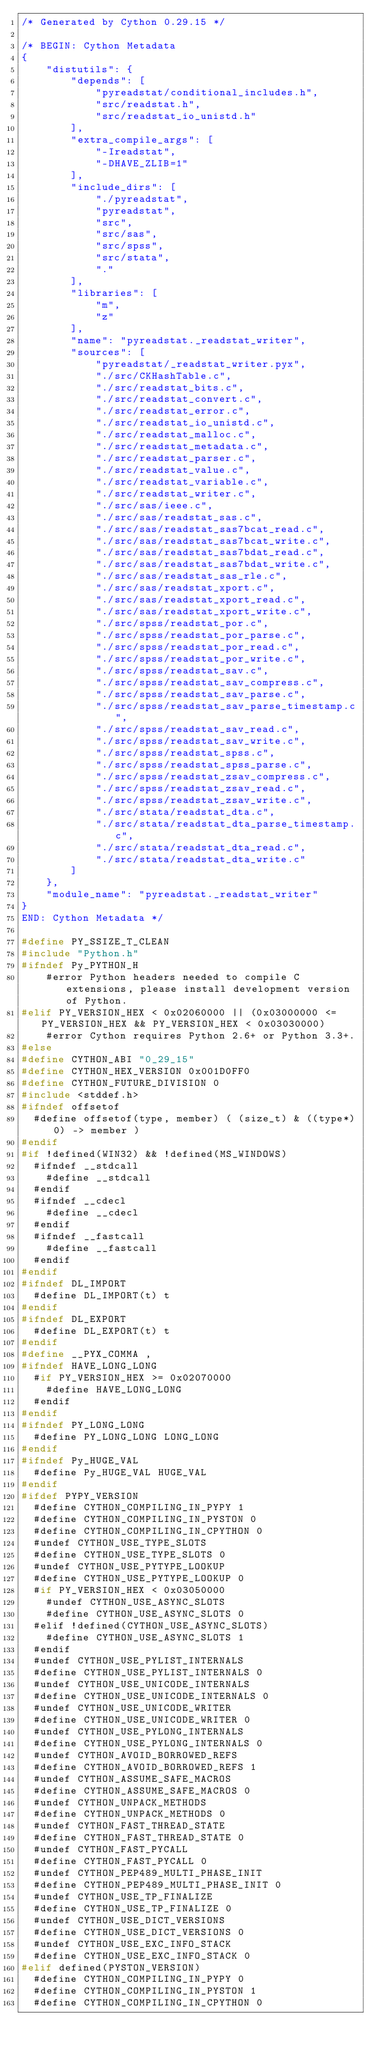Convert code to text. <code><loc_0><loc_0><loc_500><loc_500><_C_>/* Generated by Cython 0.29.15 */

/* BEGIN: Cython Metadata
{
    "distutils": {
        "depends": [
            "pyreadstat/conditional_includes.h",
            "src/readstat.h",
            "src/readstat_io_unistd.h"
        ],
        "extra_compile_args": [
            "-Ireadstat",
            "-DHAVE_ZLIB=1"
        ],
        "include_dirs": [
            "./pyreadstat",
            "pyreadstat",
            "src",
            "src/sas",
            "src/spss",
            "src/stata",
            "."
        ],
        "libraries": [
            "m",
            "z"
        ],
        "name": "pyreadstat._readstat_writer",
        "sources": [
            "pyreadstat/_readstat_writer.pyx",
            "./src/CKHashTable.c",
            "./src/readstat_bits.c",
            "./src/readstat_convert.c",
            "./src/readstat_error.c",
            "./src/readstat_io_unistd.c",
            "./src/readstat_malloc.c",
            "./src/readstat_metadata.c",
            "./src/readstat_parser.c",
            "./src/readstat_value.c",
            "./src/readstat_variable.c",
            "./src/readstat_writer.c",
            "./src/sas/ieee.c",
            "./src/sas/readstat_sas.c",
            "./src/sas/readstat_sas7bcat_read.c",
            "./src/sas/readstat_sas7bcat_write.c",
            "./src/sas/readstat_sas7bdat_read.c",
            "./src/sas/readstat_sas7bdat_write.c",
            "./src/sas/readstat_sas_rle.c",
            "./src/sas/readstat_xport.c",
            "./src/sas/readstat_xport_read.c",
            "./src/sas/readstat_xport_write.c",
            "./src/spss/readstat_por.c",
            "./src/spss/readstat_por_parse.c",
            "./src/spss/readstat_por_read.c",
            "./src/spss/readstat_por_write.c",
            "./src/spss/readstat_sav.c",
            "./src/spss/readstat_sav_compress.c",
            "./src/spss/readstat_sav_parse.c",
            "./src/spss/readstat_sav_parse_timestamp.c",
            "./src/spss/readstat_sav_read.c",
            "./src/spss/readstat_sav_write.c",
            "./src/spss/readstat_spss.c",
            "./src/spss/readstat_spss_parse.c",
            "./src/spss/readstat_zsav_compress.c",
            "./src/spss/readstat_zsav_read.c",
            "./src/spss/readstat_zsav_write.c",
            "./src/stata/readstat_dta.c",
            "./src/stata/readstat_dta_parse_timestamp.c",
            "./src/stata/readstat_dta_read.c",
            "./src/stata/readstat_dta_write.c"
        ]
    },
    "module_name": "pyreadstat._readstat_writer"
}
END: Cython Metadata */

#define PY_SSIZE_T_CLEAN
#include "Python.h"
#ifndef Py_PYTHON_H
    #error Python headers needed to compile C extensions, please install development version of Python.
#elif PY_VERSION_HEX < 0x02060000 || (0x03000000 <= PY_VERSION_HEX && PY_VERSION_HEX < 0x03030000)
    #error Cython requires Python 2.6+ or Python 3.3+.
#else
#define CYTHON_ABI "0_29_15"
#define CYTHON_HEX_VERSION 0x001D0FF0
#define CYTHON_FUTURE_DIVISION 0
#include <stddef.h>
#ifndef offsetof
  #define offsetof(type, member) ( (size_t) & ((type*)0) -> member )
#endif
#if !defined(WIN32) && !defined(MS_WINDOWS)
  #ifndef __stdcall
    #define __stdcall
  #endif
  #ifndef __cdecl
    #define __cdecl
  #endif
  #ifndef __fastcall
    #define __fastcall
  #endif
#endif
#ifndef DL_IMPORT
  #define DL_IMPORT(t) t
#endif
#ifndef DL_EXPORT
  #define DL_EXPORT(t) t
#endif
#define __PYX_COMMA ,
#ifndef HAVE_LONG_LONG
  #if PY_VERSION_HEX >= 0x02070000
    #define HAVE_LONG_LONG
  #endif
#endif
#ifndef PY_LONG_LONG
  #define PY_LONG_LONG LONG_LONG
#endif
#ifndef Py_HUGE_VAL
  #define Py_HUGE_VAL HUGE_VAL
#endif
#ifdef PYPY_VERSION
  #define CYTHON_COMPILING_IN_PYPY 1
  #define CYTHON_COMPILING_IN_PYSTON 0
  #define CYTHON_COMPILING_IN_CPYTHON 0
  #undef CYTHON_USE_TYPE_SLOTS
  #define CYTHON_USE_TYPE_SLOTS 0
  #undef CYTHON_USE_PYTYPE_LOOKUP
  #define CYTHON_USE_PYTYPE_LOOKUP 0
  #if PY_VERSION_HEX < 0x03050000
    #undef CYTHON_USE_ASYNC_SLOTS
    #define CYTHON_USE_ASYNC_SLOTS 0
  #elif !defined(CYTHON_USE_ASYNC_SLOTS)
    #define CYTHON_USE_ASYNC_SLOTS 1
  #endif
  #undef CYTHON_USE_PYLIST_INTERNALS
  #define CYTHON_USE_PYLIST_INTERNALS 0
  #undef CYTHON_USE_UNICODE_INTERNALS
  #define CYTHON_USE_UNICODE_INTERNALS 0
  #undef CYTHON_USE_UNICODE_WRITER
  #define CYTHON_USE_UNICODE_WRITER 0
  #undef CYTHON_USE_PYLONG_INTERNALS
  #define CYTHON_USE_PYLONG_INTERNALS 0
  #undef CYTHON_AVOID_BORROWED_REFS
  #define CYTHON_AVOID_BORROWED_REFS 1
  #undef CYTHON_ASSUME_SAFE_MACROS
  #define CYTHON_ASSUME_SAFE_MACROS 0
  #undef CYTHON_UNPACK_METHODS
  #define CYTHON_UNPACK_METHODS 0
  #undef CYTHON_FAST_THREAD_STATE
  #define CYTHON_FAST_THREAD_STATE 0
  #undef CYTHON_FAST_PYCALL
  #define CYTHON_FAST_PYCALL 0
  #undef CYTHON_PEP489_MULTI_PHASE_INIT
  #define CYTHON_PEP489_MULTI_PHASE_INIT 0
  #undef CYTHON_USE_TP_FINALIZE
  #define CYTHON_USE_TP_FINALIZE 0
  #undef CYTHON_USE_DICT_VERSIONS
  #define CYTHON_USE_DICT_VERSIONS 0
  #undef CYTHON_USE_EXC_INFO_STACK
  #define CYTHON_USE_EXC_INFO_STACK 0
#elif defined(PYSTON_VERSION)
  #define CYTHON_COMPILING_IN_PYPY 0
  #define CYTHON_COMPILING_IN_PYSTON 1
  #define CYTHON_COMPILING_IN_CPYTHON 0</code> 